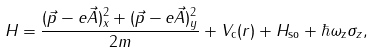Convert formula to latex. <formula><loc_0><loc_0><loc_500><loc_500>H = \frac { ( \vec { p } - e \vec { A } ) _ { x } ^ { 2 } + ( \vec { p } - e \vec { A } ) _ { y } ^ { 2 } } { 2 m } + V _ { \text {c} } ( r ) + H _ { \text {so} } + \hbar { \omega } _ { \text {z} } \sigma _ { z } ,</formula> 